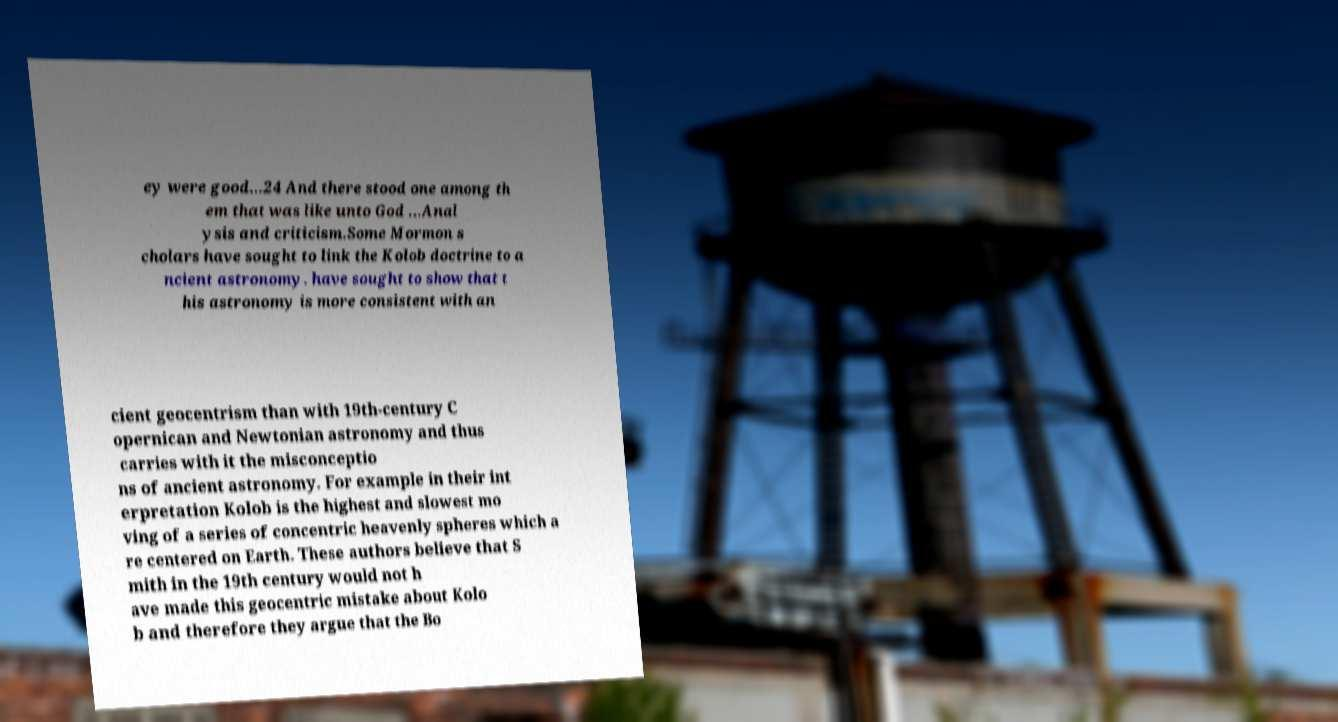There's text embedded in this image that I need extracted. Can you transcribe it verbatim? ey were good...24 And there stood one among th em that was like unto God ...Anal ysis and criticism.Some Mormon s cholars have sought to link the Kolob doctrine to a ncient astronomy. have sought to show that t his astronomy is more consistent with an cient geocentrism than with 19th-century C opernican and Newtonian astronomy and thus carries with it the misconceptio ns of ancient astronomy. For example in their int erpretation Kolob is the highest and slowest mo ving of a series of concentric heavenly spheres which a re centered on Earth. These authors believe that S mith in the 19th century would not h ave made this geocentric mistake about Kolo b and therefore they argue that the Bo 